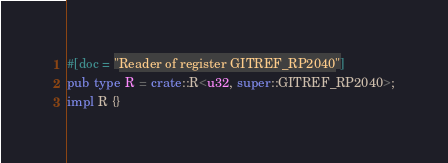Convert code to text. <code><loc_0><loc_0><loc_500><loc_500><_Rust_>#[doc = "Reader of register GITREF_RP2040"]
pub type R = crate::R<u32, super::GITREF_RP2040>;
impl R {}
</code> 